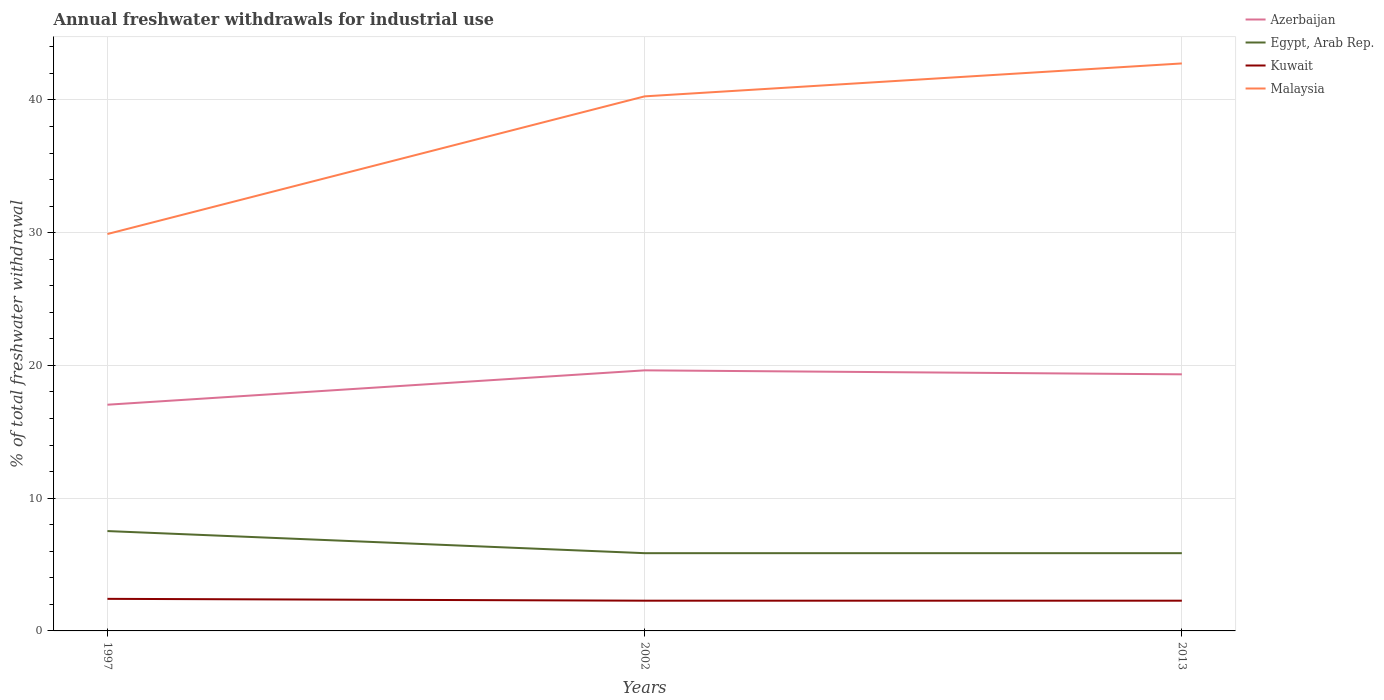How many different coloured lines are there?
Provide a short and direct response. 4. Does the line corresponding to Azerbaijan intersect with the line corresponding to Kuwait?
Keep it short and to the point. No. Across all years, what is the maximum total annual withdrawals from freshwater in Azerbaijan?
Provide a succinct answer. 17.04. In which year was the total annual withdrawals from freshwater in Azerbaijan maximum?
Give a very brief answer. 1997. What is the total total annual withdrawals from freshwater in Egypt, Arab Rep. in the graph?
Give a very brief answer. 1.67. What is the difference between the highest and the second highest total annual withdrawals from freshwater in Kuwait?
Ensure brevity in your answer.  0.14. What is the difference between the highest and the lowest total annual withdrawals from freshwater in Kuwait?
Ensure brevity in your answer.  1. Is the total annual withdrawals from freshwater in Kuwait strictly greater than the total annual withdrawals from freshwater in Malaysia over the years?
Give a very brief answer. Yes. How many lines are there?
Offer a very short reply. 4. How many years are there in the graph?
Offer a terse response. 3. Are the values on the major ticks of Y-axis written in scientific E-notation?
Ensure brevity in your answer.  No. Does the graph contain any zero values?
Make the answer very short. No. How many legend labels are there?
Offer a very short reply. 4. What is the title of the graph?
Offer a terse response. Annual freshwater withdrawals for industrial use. What is the label or title of the X-axis?
Your answer should be compact. Years. What is the label or title of the Y-axis?
Offer a terse response. % of total freshwater withdrawal. What is the % of total freshwater withdrawal in Azerbaijan in 1997?
Offer a terse response. 17.04. What is the % of total freshwater withdrawal of Egypt, Arab Rep. in 1997?
Keep it short and to the point. 7.52. What is the % of total freshwater withdrawal of Kuwait in 1997?
Your answer should be compact. 2.42. What is the % of total freshwater withdrawal in Malaysia in 1997?
Provide a short and direct response. 29.9. What is the % of total freshwater withdrawal of Azerbaijan in 2002?
Offer a very short reply. 19.63. What is the % of total freshwater withdrawal in Egypt, Arab Rep. in 2002?
Your answer should be compact. 5.86. What is the % of total freshwater withdrawal of Kuwait in 2002?
Offer a terse response. 2.28. What is the % of total freshwater withdrawal of Malaysia in 2002?
Offer a very short reply. 40.27. What is the % of total freshwater withdrawal of Azerbaijan in 2013?
Provide a succinct answer. 19.33. What is the % of total freshwater withdrawal in Egypt, Arab Rep. in 2013?
Offer a very short reply. 5.86. What is the % of total freshwater withdrawal in Kuwait in 2013?
Offer a very short reply. 2.28. What is the % of total freshwater withdrawal in Malaysia in 2013?
Your response must be concise. 42.75. Across all years, what is the maximum % of total freshwater withdrawal in Azerbaijan?
Offer a terse response. 19.63. Across all years, what is the maximum % of total freshwater withdrawal of Egypt, Arab Rep.?
Make the answer very short. 7.52. Across all years, what is the maximum % of total freshwater withdrawal in Kuwait?
Ensure brevity in your answer.  2.42. Across all years, what is the maximum % of total freshwater withdrawal in Malaysia?
Your answer should be very brief. 42.75. Across all years, what is the minimum % of total freshwater withdrawal in Azerbaijan?
Your answer should be compact. 17.04. Across all years, what is the minimum % of total freshwater withdrawal in Egypt, Arab Rep.?
Offer a terse response. 5.86. Across all years, what is the minimum % of total freshwater withdrawal in Kuwait?
Your response must be concise. 2.28. Across all years, what is the minimum % of total freshwater withdrawal of Malaysia?
Your answer should be compact. 29.9. What is the total % of total freshwater withdrawal of Azerbaijan in the graph?
Keep it short and to the point. 56. What is the total % of total freshwater withdrawal of Egypt, Arab Rep. in the graph?
Offer a very short reply. 19.24. What is the total % of total freshwater withdrawal in Kuwait in the graph?
Offer a very short reply. 6.97. What is the total % of total freshwater withdrawal in Malaysia in the graph?
Ensure brevity in your answer.  112.92. What is the difference between the % of total freshwater withdrawal of Azerbaijan in 1997 and that in 2002?
Offer a terse response. -2.59. What is the difference between the % of total freshwater withdrawal of Egypt, Arab Rep. in 1997 and that in 2002?
Make the answer very short. 1.67. What is the difference between the % of total freshwater withdrawal in Kuwait in 1997 and that in 2002?
Give a very brief answer. 0.14. What is the difference between the % of total freshwater withdrawal of Malaysia in 1997 and that in 2002?
Make the answer very short. -10.37. What is the difference between the % of total freshwater withdrawal of Azerbaijan in 1997 and that in 2013?
Offer a very short reply. -2.29. What is the difference between the % of total freshwater withdrawal of Egypt, Arab Rep. in 1997 and that in 2013?
Your response must be concise. 1.67. What is the difference between the % of total freshwater withdrawal in Kuwait in 1997 and that in 2013?
Provide a succinct answer. 0.14. What is the difference between the % of total freshwater withdrawal in Malaysia in 1997 and that in 2013?
Make the answer very short. -12.85. What is the difference between the % of total freshwater withdrawal in Azerbaijan in 2002 and that in 2013?
Provide a succinct answer. 0.3. What is the difference between the % of total freshwater withdrawal in Egypt, Arab Rep. in 2002 and that in 2013?
Offer a terse response. 0. What is the difference between the % of total freshwater withdrawal in Kuwait in 2002 and that in 2013?
Provide a short and direct response. 0. What is the difference between the % of total freshwater withdrawal in Malaysia in 2002 and that in 2013?
Your response must be concise. -2.48. What is the difference between the % of total freshwater withdrawal of Azerbaijan in 1997 and the % of total freshwater withdrawal of Egypt, Arab Rep. in 2002?
Offer a terse response. 11.18. What is the difference between the % of total freshwater withdrawal of Azerbaijan in 1997 and the % of total freshwater withdrawal of Kuwait in 2002?
Offer a terse response. 14.76. What is the difference between the % of total freshwater withdrawal in Azerbaijan in 1997 and the % of total freshwater withdrawal in Malaysia in 2002?
Keep it short and to the point. -23.23. What is the difference between the % of total freshwater withdrawal in Egypt, Arab Rep. in 1997 and the % of total freshwater withdrawal in Kuwait in 2002?
Offer a very short reply. 5.25. What is the difference between the % of total freshwater withdrawal of Egypt, Arab Rep. in 1997 and the % of total freshwater withdrawal of Malaysia in 2002?
Keep it short and to the point. -32.75. What is the difference between the % of total freshwater withdrawal of Kuwait in 1997 and the % of total freshwater withdrawal of Malaysia in 2002?
Offer a very short reply. -37.85. What is the difference between the % of total freshwater withdrawal of Azerbaijan in 1997 and the % of total freshwater withdrawal of Egypt, Arab Rep. in 2013?
Your answer should be very brief. 11.18. What is the difference between the % of total freshwater withdrawal in Azerbaijan in 1997 and the % of total freshwater withdrawal in Kuwait in 2013?
Give a very brief answer. 14.76. What is the difference between the % of total freshwater withdrawal in Azerbaijan in 1997 and the % of total freshwater withdrawal in Malaysia in 2013?
Your answer should be compact. -25.71. What is the difference between the % of total freshwater withdrawal of Egypt, Arab Rep. in 1997 and the % of total freshwater withdrawal of Kuwait in 2013?
Your answer should be compact. 5.25. What is the difference between the % of total freshwater withdrawal in Egypt, Arab Rep. in 1997 and the % of total freshwater withdrawal in Malaysia in 2013?
Offer a terse response. -35.23. What is the difference between the % of total freshwater withdrawal of Kuwait in 1997 and the % of total freshwater withdrawal of Malaysia in 2013?
Provide a succinct answer. -40.33. What is the difference between the % of total freshwater withdrawal of Azerbaijan in 2002 and the % of total freshwater withdrawal of Egypt, Arab Rep. in 2013?
Provide a short and direct response. 13.77. What is the difference between the % of total freshwater withdrawal of Azerbaijan in 2002 and the % of total freshwater withdrawal of Kuwait in 2013?
Provide a short and direct response. 17.35. What is the difference between the % of total freshwater withdrawal of Azerbaijan in 2002 and the % of total freshwater withdrawal of Malaysia in 2013?
Keep it short and to the point. -23.12. What is the difference between the % of total freshwater withdrawal of Egypt, Arab Rep. in 2002 and the % of total freshwater withdrawal of Kuwait in 2013?
Keep it short and to the point. 3.58. What is the difference between the % of total freshwater withdrawal in Egypt, Arab Rep. in 2002 and the % of total freshwater withdrawal in Malaysia in 2013?
Your answer should be compact. -36.89. What is the difference between the % of total freshwater withdrawal of Kuwait in 2002 and the % of total freshwater withdrawal of Malaysia in 2013?
Provide a short and direct response. -40.47. What is the average % of total freshwater withdrawal of Azerbaijan per year?
Make the answer very short. 18.67. What is the average % of total freshwater withdrawal of Egypt, Arab Rep. per year?
Provide a succinct answer. 6.41. What is the average % of total freshwater withdrawal in Kuwait per year?
Make the answer very short. 2.32. What is the average % of total freshwater withdrawal in Malaysia per year?
Give a very brief answer. 37.64. In the year 1997, what is the difference between the % of total freshwater withdrawal of Azerbaijan and % of total freshwater withdrawal of Egypt, Arab Rep.?
Ensure brevity in your answer.  9.52. In the year 1997, what is the difference between the % of total freshwater withdrawal in Azerbaijan and % of total freshwater withdrawal in Kuwait?
Make the answer very short. 14.62. In the year 1997, what is the difference between the % of total freshwater withdrawal of Azerbaijan and % of total freshwater withdrawal of Malaysia?
Offer a very short reply. -12.86. In the year 1997, what is the difference between the % of total freshwater withdrawal of Egypt, Arab Rep. and % of total freshwater withdrawal of Kuwait?
Keep it short and to the point. 5.11. In the year 1997, what is the difference between the % of total freshwater withdrawal in Egypt, Arab Rep. and % of total freshwater withdrawal in Malaysia?
Provide a succinct answer. -22.38. In the year 1997, what is the difference between the % of total freshwater withdrawal of Kuwait and % of total freshwater withdrawal of Malaysia?
Provide a short and direct response. -27.48. In the year 2002, what is the difference between the % of total freshwater withdrawal in Azerbaijan and % of total freshwater withdrawal in Egypt, Arab Rep.?
Offer a very short reply. 13.77. In the year 2002, what is the difference between the % of total freshwater withdrawal of Azerbaijan and % of total freshwater withdrawal of Kuwait?
Provide a short and direct response. 17.35. In the year 2002, what is the difference between the % of total freshwater withdrawal in Azerbaijan and % of total freshwater withdrawal in Malaysia?
Offer a very short reply. -20.64. In the year 2002, what is the difference between the % of total freshwater withdrawal in Egypt, Arab Rep. and % of total freshwater withdrawal in Kuwait?
Offer a terse response. 3.58. In the year 2002, what is the difference between the % of total freshwater withdrawal in Egypt, Arab Rep. and % of total freshwater withdrawal in Malaysia?
Offer a terse response. -34.41. In the year 2002, what is the difference between the % of total freshwater withdrawal of Kuwait and % of total freshwater withdrawal of Malaysia?
Your answer should be very brief. -37.99. In the year 2013, what is the difference between the % of total freshwater withdrawal of Azerbaijan and % of total freshwater withdrawal of Egypt, Arab Rep.?
Your response must be concise. 13.47. In the year 2013, what is the difference between the % of total freshwater withdrawal in Azerbaijan and % of total freshwater withdrawal in Kuwait?
Give a very brief answer. 17.05. In the year 2013, what is the difference between the % of total freshwater withdrawal of Azerbaijan and % of total freshwater withdrawal of Malaysia?
Ensure brevity in your answer.  -23.42. In the year 2013, what is the difference between the % of total freshwater withdrawal of Egypt, Arab Rep. and % of total freshwater withdrawal of Kuwait?
Provide a short and direct response. 3.58. In the year 2013, what is the difference between the % of total freshwater withdrawal of Egypt, Arab Rep. and % of total freshwater withdrawal of Malaysia?
Make the answer very short. -36.89. In the year 2013, what is the difference between the % of total freshwater withdrawal in Kuwait and % of total freshwater withdrawal in Malaysia?
Make the answer very short. -40.47. What is the ratio of the % of total freshwater withdrawal of Azerbaijan in 1997 to that in 2002?
Your answer should be very brief. 0.87. What is the ratio of the % of total freshwater withdrawal of Egypt, Arab Rep. in 1997 to that in 2002?
Your answer should be very brief. 1.28. What is the ratio of the % of total freshwater withdrawal in Kuwait in 1997 to that in 2002?
Keep it short and to the point. 1.06. What is the ratio of the % of total freshwater withdrawal of Malaysia in 1997 to that in 2002?
Offer a very short reply. 0.74. What is the ratio of the % of total freshwater withdrawal in Azerbaijan in 1997 to that in 2013?
Provide a short and direct response. 0.88. What is the ratio of the % of total freshwater withdrawal in Egypt, Arab Rep. in 1997 to that in 2013?
Your response must be concise. 1.28. What is the ratio of the % of total freshwater withdrawal of Kuwait in 1997 to that in 2013?
Make the answer very short. 1.06. What is the ratio of the % of total freshwater withdrawal in Malaysia in 1997 to that in 2013?
Offer a terse response. 0.7. What is the ratio of the % of total freshwater withdrawal of Azerbaijan in 2002 to that in 2013?
Give a very brief answer. 1.02. What is the ratio of the % of total freshwater withdrawal in Malaysia in 2002 to that in 2013?
Give a very brief answer. 0.94. What is the difference between the highest and the second highest % of total freshwater withdrawal in Azerbaijan?
Your answer should be very brief. 0.3. What is the difference between the highest and the second highest % of total freshwater withdrawal of Egypt, Arab Rep.?
Offer a terse response. 1.67. What is the difference between the highest and the second highest % of total freshwater withdrawal of Kuwait?
Your answer should be very brief. 0.14. What is the difference between the highest and the second highest % of total freshwater withdrawal in Malaysia?
Provide a succinct answer. 2.48. What is the difference between the highest and the lowest % of total freshwater withdrawal in Azerbaijan?
Your answer should be very brief. 2.59. What is the difference between the highest and the lowest % of total freshwater withdrawal of Egypt, Arab Rep.?
Your answer should be very brief. 1.67. What is the difference between the highest and the lowest % of total freshwater withdrawal of Kuwait?
Provide a short and direct response. 0.14. What is the difference between the highest and the lowest % of total freshwater withdrawal of Malaysia?
Make the answer very short. 12.85. 